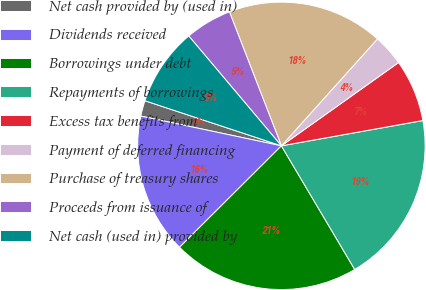Convert chart to OTSL. <chart><loc_0><loc_0><loc_500><loc_500><pie_chart><fcel>Net cash provided by (used in)<fcel>Dividends received<fcel>Borrowings under debt<fcel>Repayments of borrowings<fcel>Excess tax benefits from<fcel>Payment of deferred financing<fcel>Purchase of treasury shares<fcel>Proceeds from issuance of<fcel>Net cash (used in) provided by<nl><fcel>1.76%<fcel>15.79%<fcel>21.05%<fcel>19.3%<fcel>7.02%<fcel>3.51%<fcel>17.54%<fcel>5.26%<fcel>8.77%<nl></chart> 